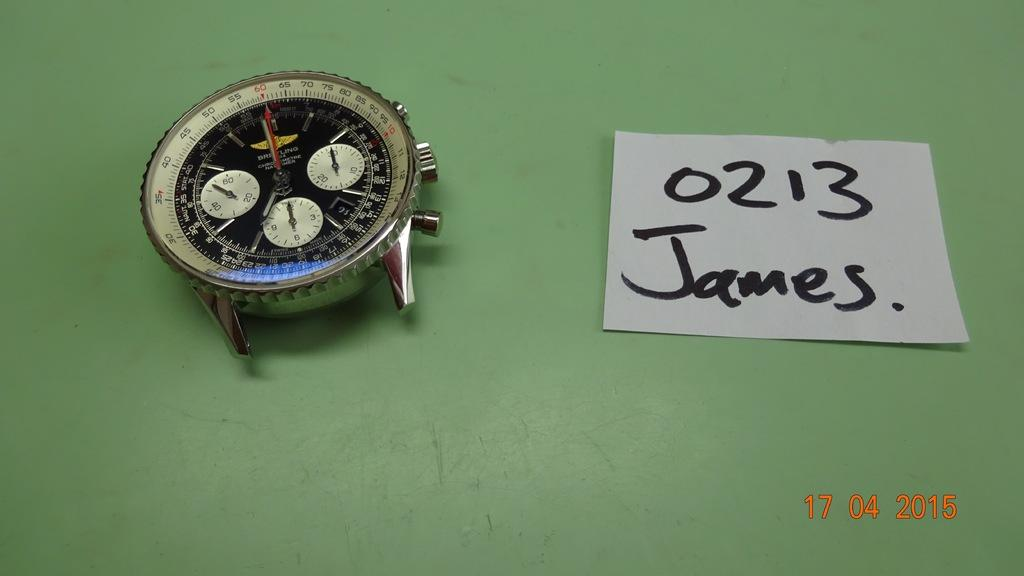<image>
Summarize the visual content of the image. Watch displayed on a green table with 0213 James beside it 